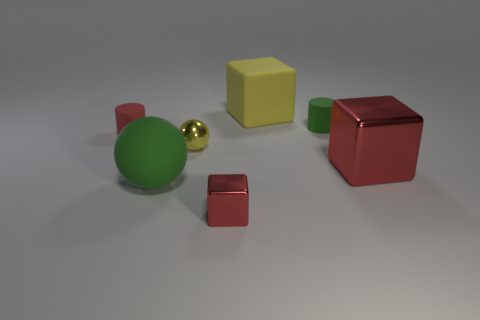What number of objects are large things right of the large green ball or yellow metal objects?
Offer a terse response. 3. Do the large shiny cube and the tiny shiny cube have the same color?
Make the answer very short. Yes. There is a shiny thing on the left side of the tiny metal block; what is its size?
Ensure brevity in your answer.  Small. Are there any balls of the same size as the green cylinder?
Offer a very short reply. Yes. There is a matte object that is in front of the yellow metallic ball; is its size the same as the red rubber object?
Your answer should be compact. No. What size is the yellow rubber block?
Offer a terse response. Large. There is a big block that is behind the red block that is to the right of the small matte cylinder that is right of the large yellow block; what color is it?
Your answer should be very brief. Yellow. There is a cylinder behind the tiny red rubber object; is it the same color as the matte sphere?
Offer a very short reply. Yes. What number of red cubes are both to the left of the tiny green cylinder and behind the large green thing?
Keep it short and to the point. 0. What is the size of the other red metal thing that is the same shape as the big red metallic object?
Offer a terse response. Small. 